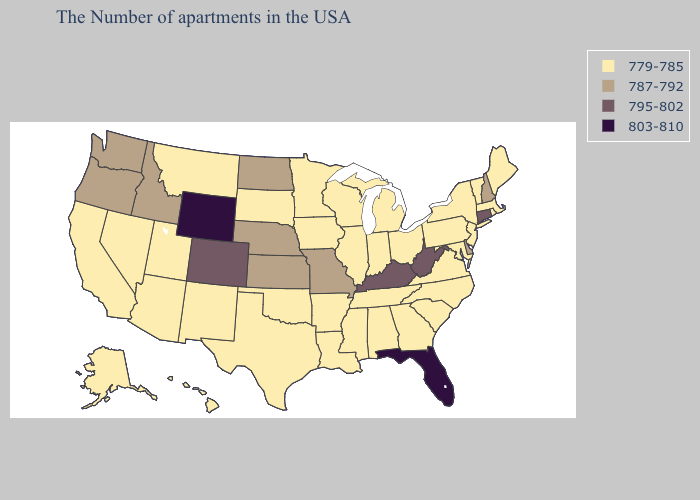Among the states that border Tennessee , does Arkansas have the highest value?
Give a very brief answer. No. Does Wyoming have the highest value in the USA?
Give a very brief answer. Yes. Name the states that have a value in the range 787-792?
Give a very brief answer. New Hampshire, Delaware, Missouri, Kansas, Nebraska, North Dakota, Idaho, Washington, Oregon. Does the first symbol in the legend represent the smallest category?
Short answer required. Yes. Which states have the highest value in the USA?
Concise answer only. Florida, Wyoming. What is the value of Kentucky?
Answer briefly. 795-802. What is the value of Maine?
Concise answer only. 779-785. What is the value of Montana?
Answer briefly. 779-785. Does New Hampshire have the lowest value in the USA?
Short answer required. No. Does the map have missing data?
Concise answer only. No. What is the value of New Jersey?
Be succinct. 779-785. Among the states that border Vermont , which have the highest value?
Write a very short answer. New Hampshire. What is the value of Washington?
Concise answer only. 787-792. Is the legend a continuous bar?
Keep it brief. No. What is the highest value in the USA?
Short answer required. 803-810. 